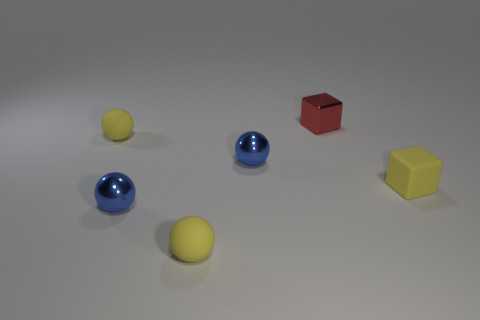Does the blue thing behind the matte block have the same size as the tiny red object?
Provide a short and direct response. Yes. Is the number of metal cubes greater than the number of blue spheres?
Provide a short and direct response. No. What number of small objects are either yellow matte things or metal things?
Provide a succinct answer. 6. How many other things are the same color as the small rubber cube?
Offer a very short reply. 2. How many small blue spheres are the same material as the small yellow cube?
Your response must be concise. 0. Is the color of the matte object that is on the right side of the small metallic block the same as the tiny metallic block?
Keep it short and to the point. No. What number of purple things are rubber objects or small cubes?
Offer a very short reply. 0. Is there anything else that is the same material as the yellow cube?
Keep it short and to the point. Yes. Is the material of the tiny red block that is behind the small yellow cube the same as the small yellow cube?
Your answer should be compact. No. What number of things are either tiny red matte things or small rubber things that are in front of the yellow cube?
Offer a terse response. 1. 